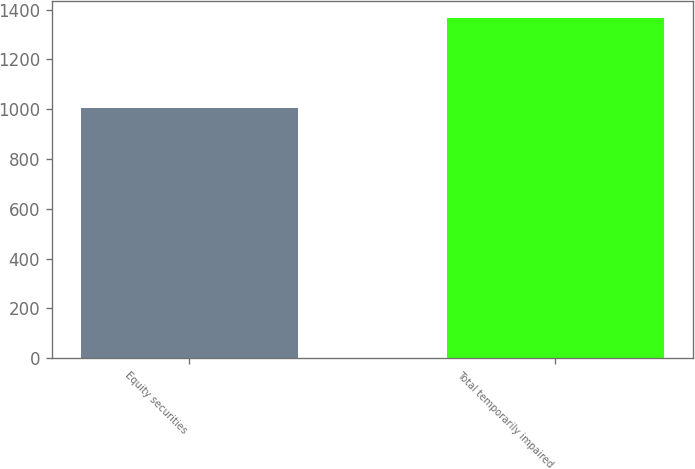Convert chart. <chart><loc_0><loc_0><loc_500><loc_500><bar_chart><fcel>Equity securities<fcel>Total temporarily impaired<nl><fcel>1006<fcel>1368<nl></chart> 